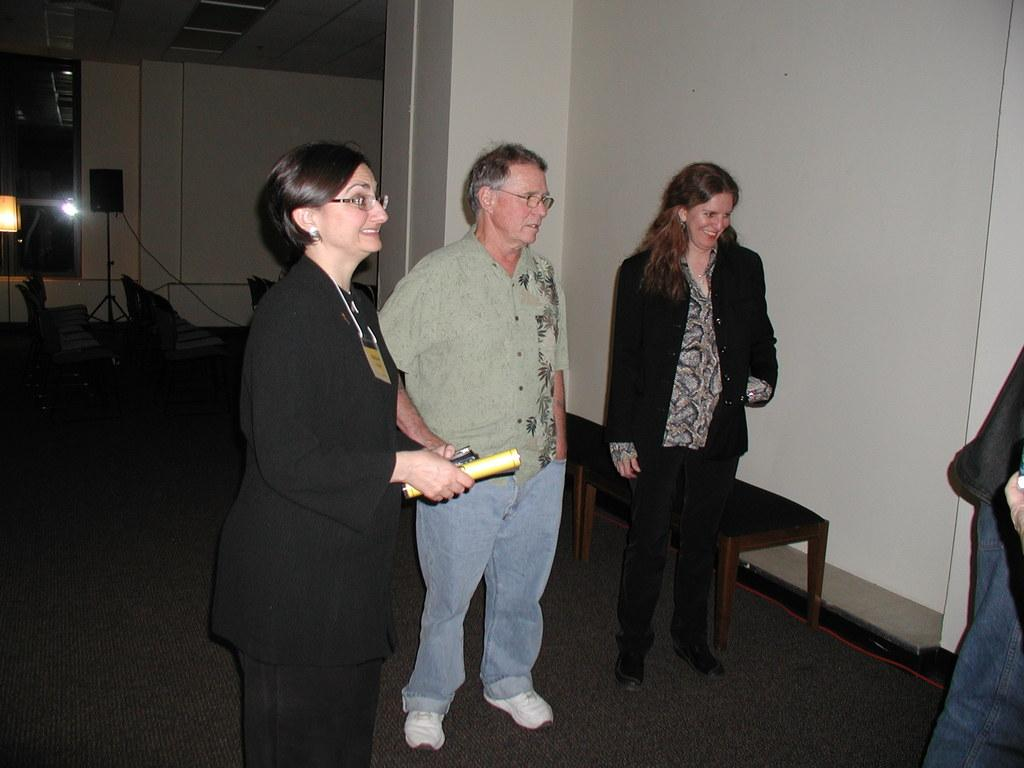What are the people in the image doing? The people in the image are standing. What is the woman holding in the image? The woman is holding papers in the image. Can you describe the seating arrangement in the image? There are chairs visible on both sides of the image. What type of equipment is present in the room? Speaker boxes are present in the room. What type of flowers can be seen on the table in the image? There are no flowers present in the image; it only features people, a woman holding papers, chairs, and speaker boxes. 